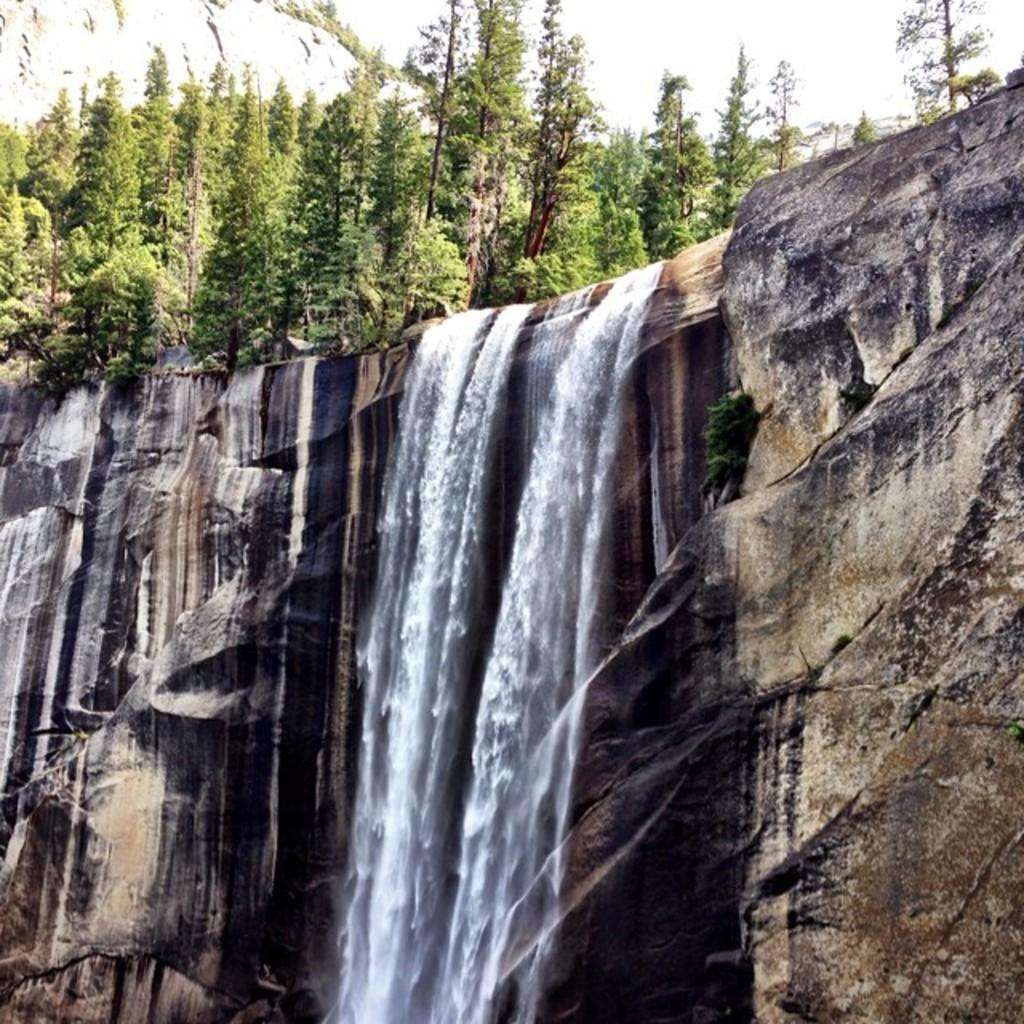What natural feature is the main subject of the image? There is a waterfall in the image. What type of vegetation can be seen in the background of the image? There are trees visible in the background of the image. What type of hose is being used to play with the waterfall in the image? There is no hose or any indication of playing with the waterfall in the image. 